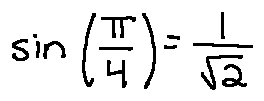Convert formula to latex. <formula><loc_0><loc_0><loc_500><loc_500>\sin ( \frac { \pi } { 4 } ) = \frac { 1 } { \sqrt { 2 } }</formula> 